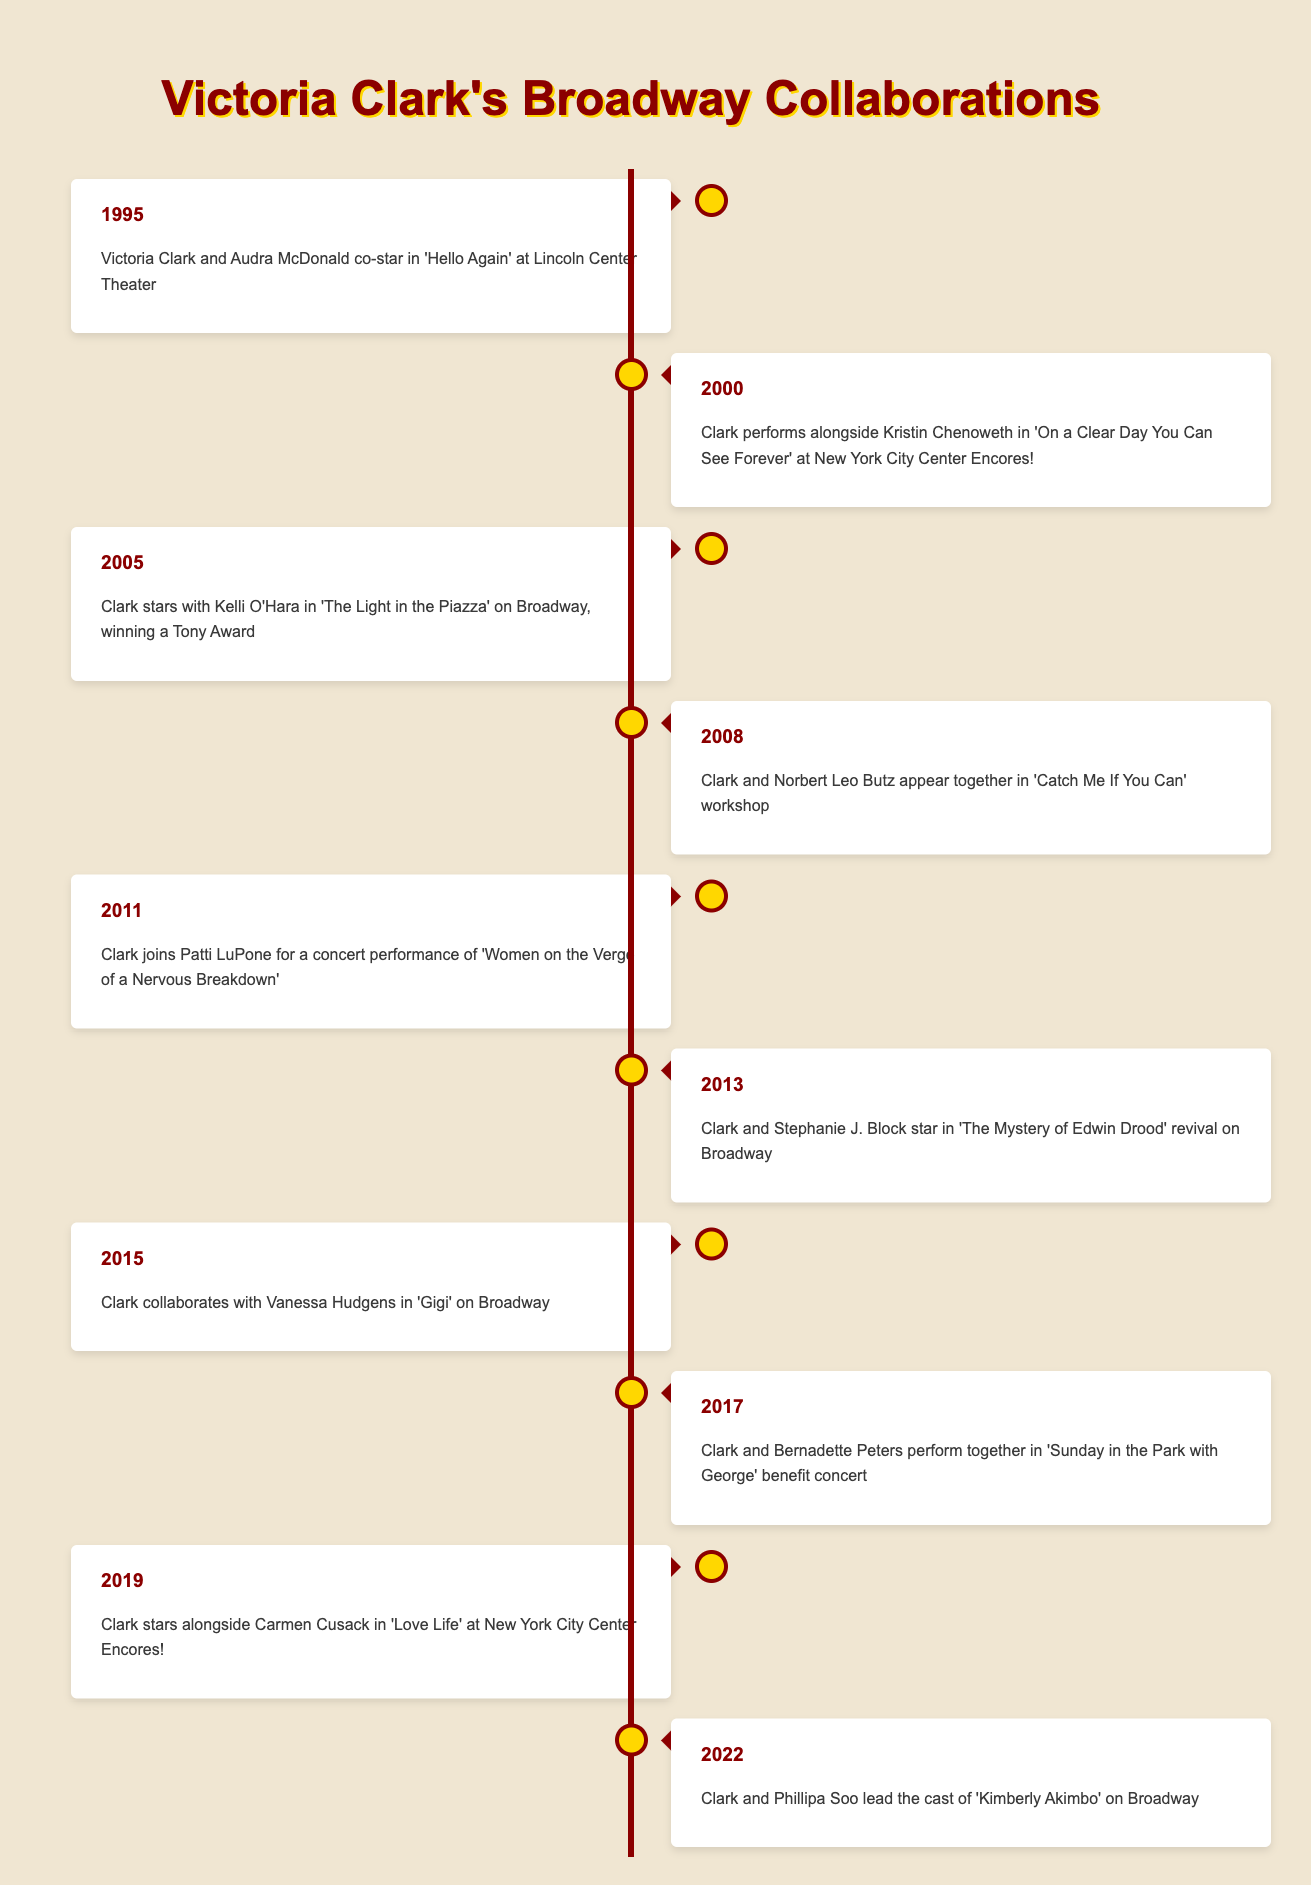What year did Victoria Clark co-star with Audra McDonald? The table shows that Victoria Clark and Audra McDonald co-starred in 'Hello Again' at Lincoln Center Theater in 1995.
Answer: 1995 In which show did Victoria Clark perform alongside Kristin Chenoweth? According to the timeline, Victoria Clark performed alongside Kristin Chenoweth in 'On a Clear Day You Can See Forever' at New York City Center Encores! in 2000.
Answer: On a Clear Day You Can See Forever How many Broadway collaborations did Victoria Clark have between 1995 and 2005? The table shows collaborations in 1995 ('Hello Again'), 2000 ('On a Clear Day You Can See Forever'), and 2005 ('The Light in the Piazza'), totaling three collaborations within that period.
Answer: 3 Did Victoria Clark ever perform with Bernadette Peters? Yes, the timeline indicates that Victoria Clark and Bernadette Peters performed together in 'Sunday in the Park with George' benefit concert in 2017.
Answer: Yes What is the difference in years between the first and last collaborations listed in the table? The first collaboration was in 1995 and the last was in 2022. The difference in years is 2022 - 1995 = 27 years.
Answer: 27 years Which two performers did Victoria Clark collaborate with in the year 2013? In 2013, Victoria Clark collaborated with Stephanie J. Block in 'The Mystery of Edwin Drood' revival on Broadway; no second performer is mentioned in that year, indicating only one collaborator.
Answer: Stephanie J. Block Which collaboration was associated with a Tony Award win? The timeline specifies that Victoria Clark starred with Kelli O'Hara in 'The Light in the Piazza' on Broadway in 2005 and won a Tony Award for this role.
Answer: The Light in the Piazza How many collaborations involved musicals at New York City Center Encores? Two collaborations involved musicals at New York City Center Encores: 'On a Clear Day You Can See Forever' in 2000 and 'Love Life' in 2019.
Answer: 2 What is the earliest year listed for Victoria Clark's collaborations? The earliest year in the table is 1995, where she co-starred with Audra McDonald in 'Hello Again'.
Answer: 1995 